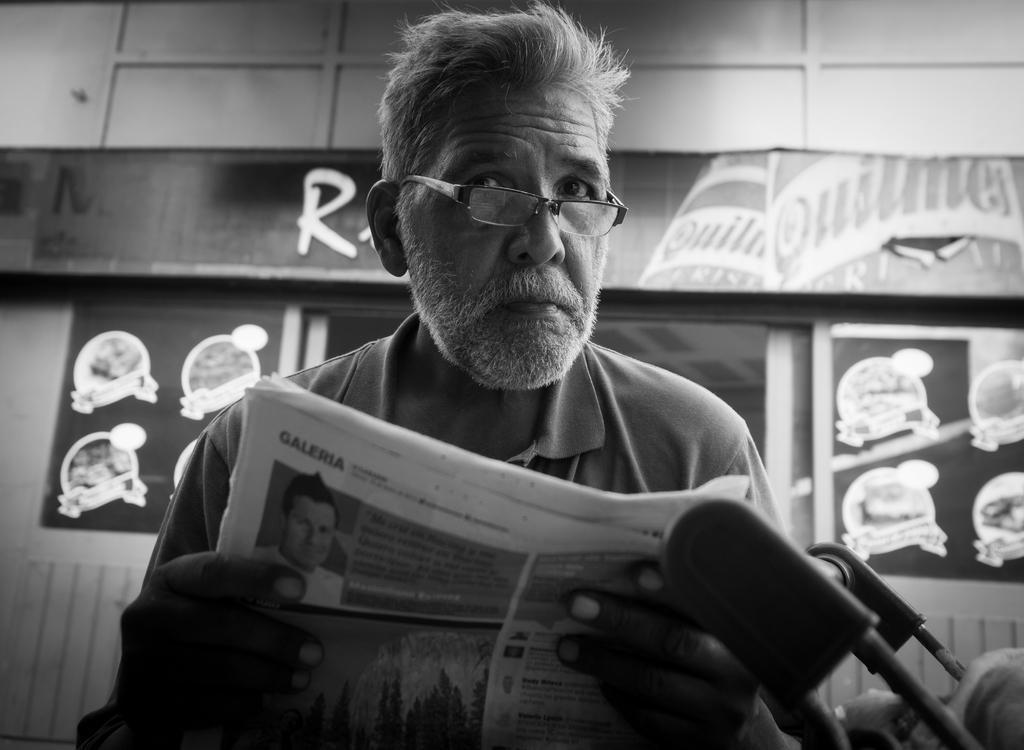How would you summarize this image in a sentence or two? In this image I can see the black and white picture in which I can see a person wearing spectacles is holding a paper in his hands. In the background I can see the wall, a board and few posters to the wall. 